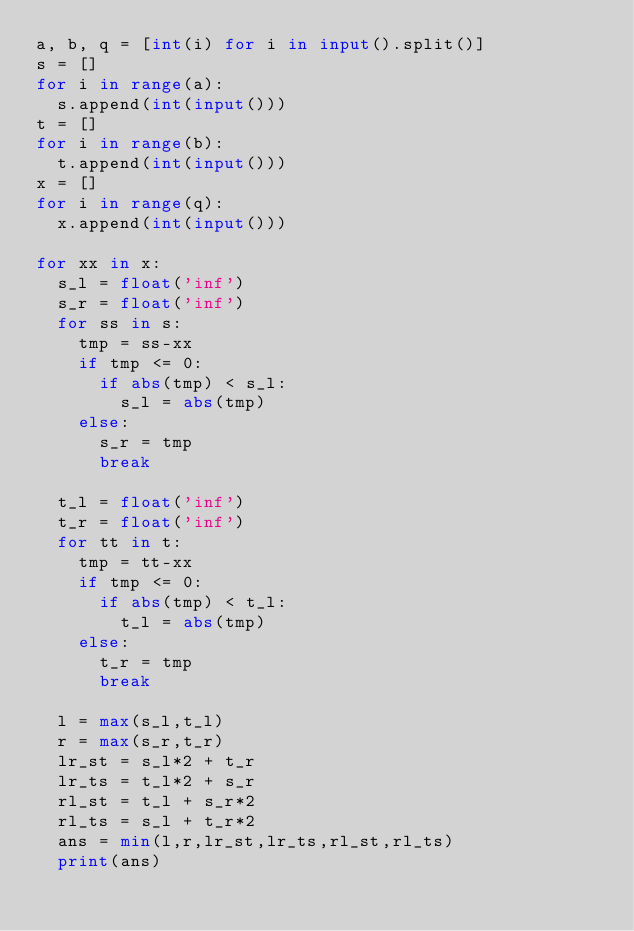<code> <loc_0><loc_0><loc_500><loc_500><_Python_>a, b, q = [int(i) for i in input().split()]
s = []
for i in range(a):
	s.append(int(input()))
t = []
for i in range(b):
	t.append(int(input()))
x = []
for i in range(q):
	x.append(int(input()))

for xx in x:
  s_l = float('inf')
  s_r = float('inf')
  for ss in s:
    tmp = ss-xx
    if tmp <= 0:
      if abs(tmp) < s_l:
        s_l = abs(tmp)
    else:
      s_r = tmp
      break

  t_l = float('inf')
  t_r = float('inf')      
  for tt in t:
    tmp = tt-xx
    if tmp <= 0:
      if abs(tmp) < t_l:
        t_l = abs(tmp)
    else:
      t_r = tmp
      break
  
  l = max(s_l,t_l)
  r = max(s_r,t_r)
  lr_st = s_l*2 + t_r
  lr_ts = t_l*2 + s_r
  rl_st = t_l + s_r*2
  rl_ts = s_l + t_r*2
  ans = min(l,r,lr_st,lr_ts,rl_st,rl_ts)
  print(ans)
  </code> 